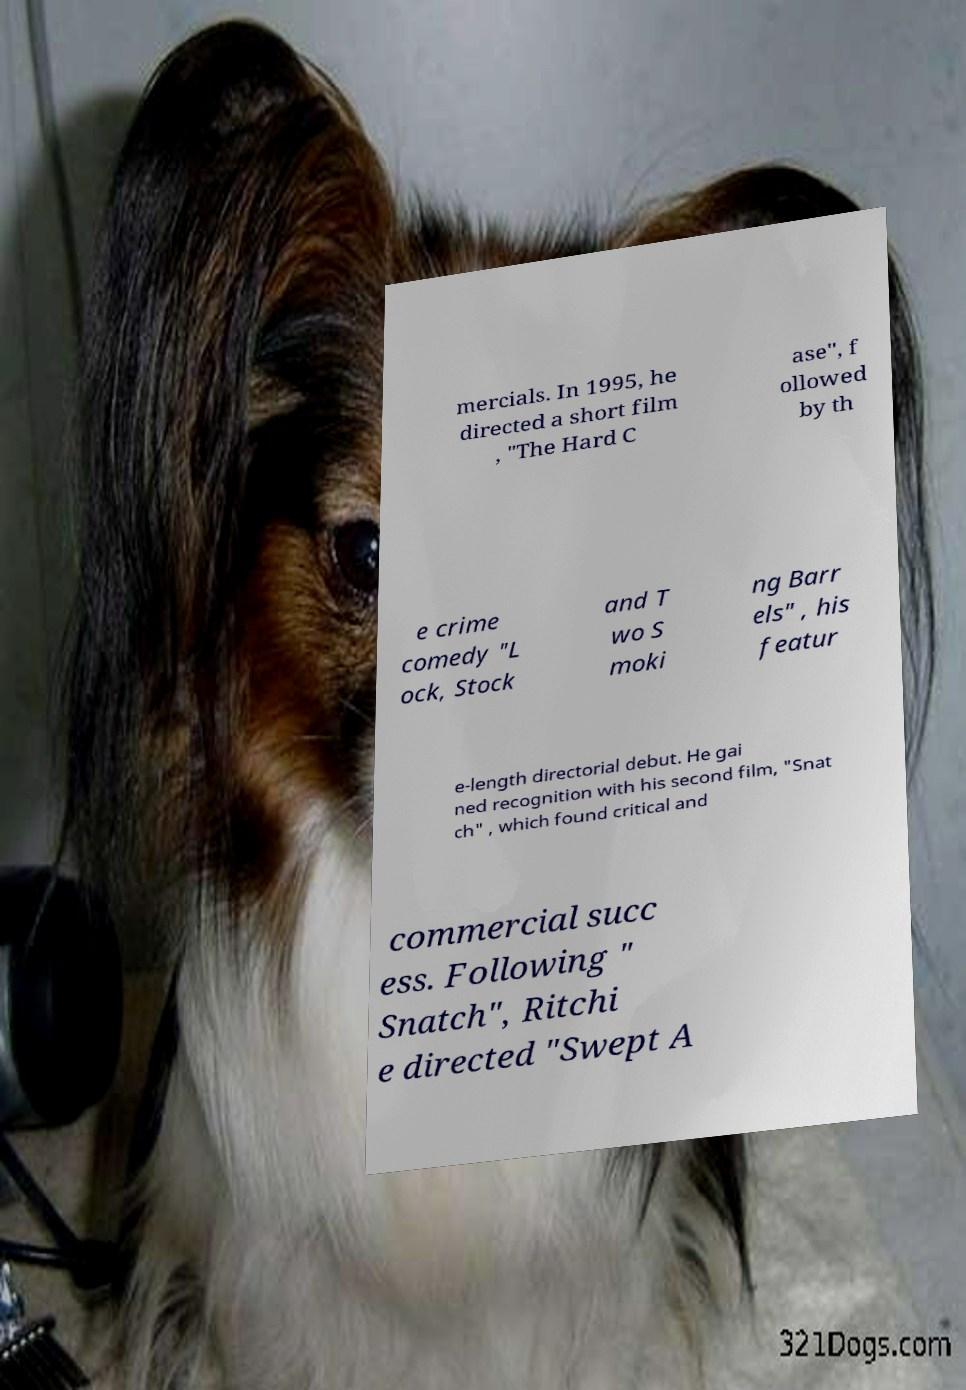Please read and relay the text visible in this image. What does it say? mercials. In 1995, he directed a short film , "The Hard C ase", f ollowed by th e crime comedy "L ock, Stock and T wo S moki ng Barr els" , his featur e-length directorial debut. He gai ned recognition with his second film, "Snat ch" , which found critical and commercial succ ess. Following " Snatch", Ritchi e directed "Swept A 